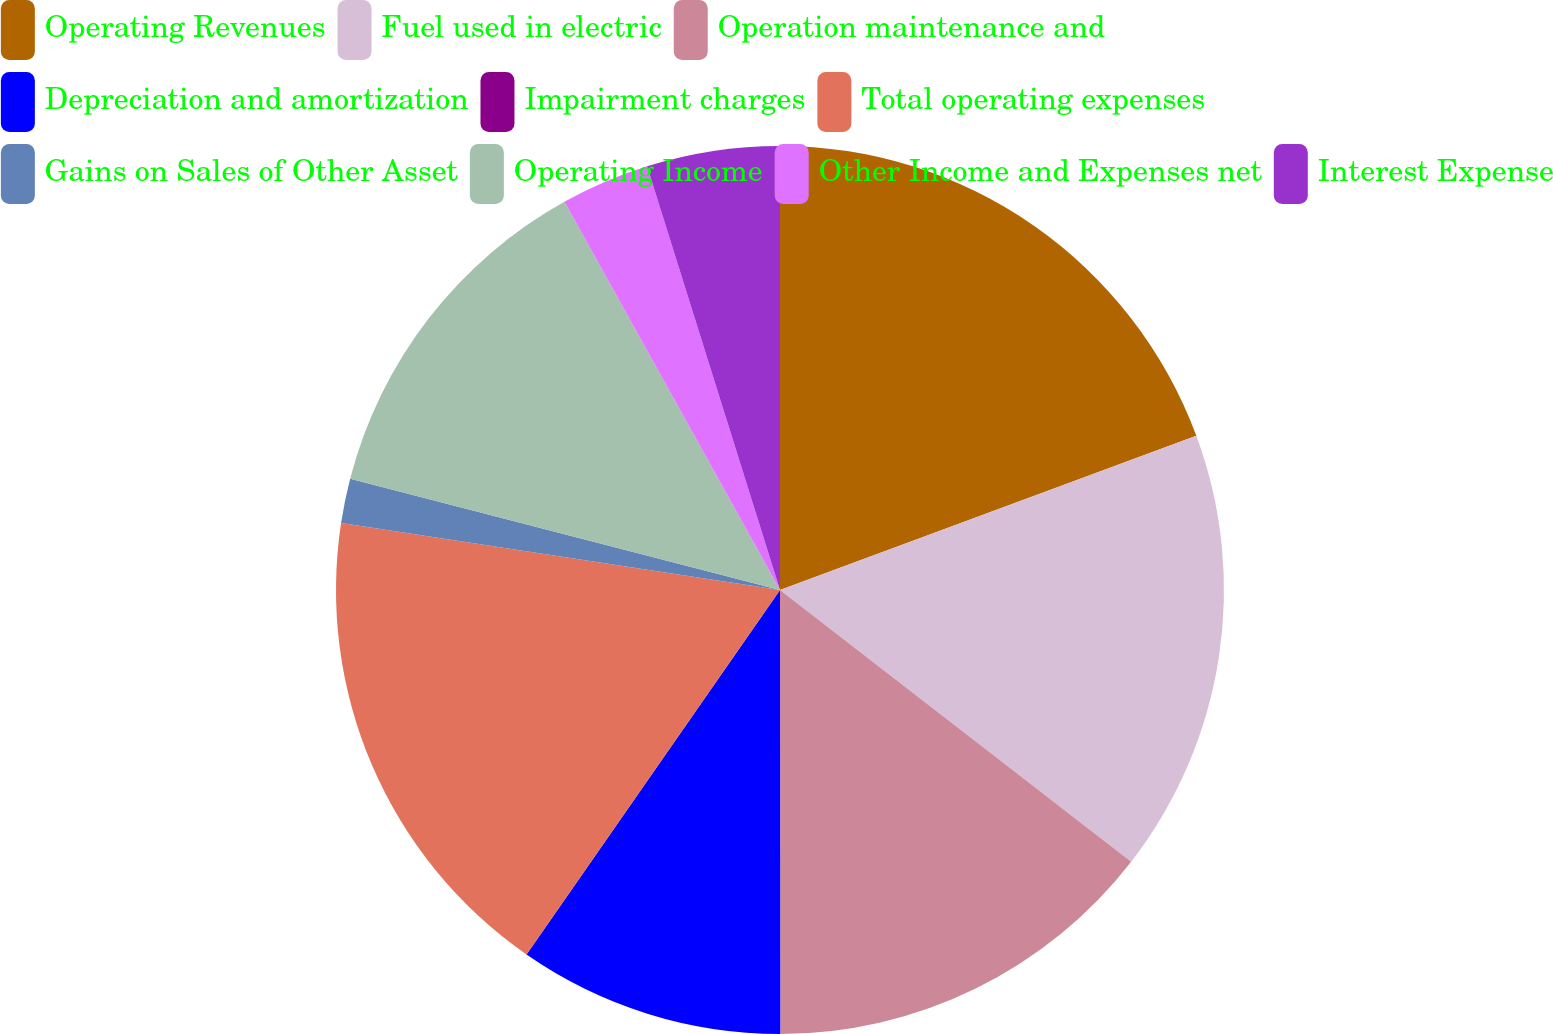Convert chart. <chart><loc_0><loc_0><loc_500><loc_500><pie_chart><fcel>Operating Revenues<fcel>Fuel used in electric<fcel>Operation maintenance and<fcel>Depreciation and amortization<fcel>Impairment charges<fcel>Total operating expenses<fcel>Gains on Sales of Other Asset<fcel>Operating Income<fcel>Other Income and Expenses net<fcel>Interest Expense<nl><fcel>19.35%<fcel>16.13%<fcel>14.51%<fcel>9.68%<fcel>0.0%<fcel>17.74%<fcel>1.62%<fcel>12.9%<fcel>3.23%<fcel>4.84%<nl></chart> 